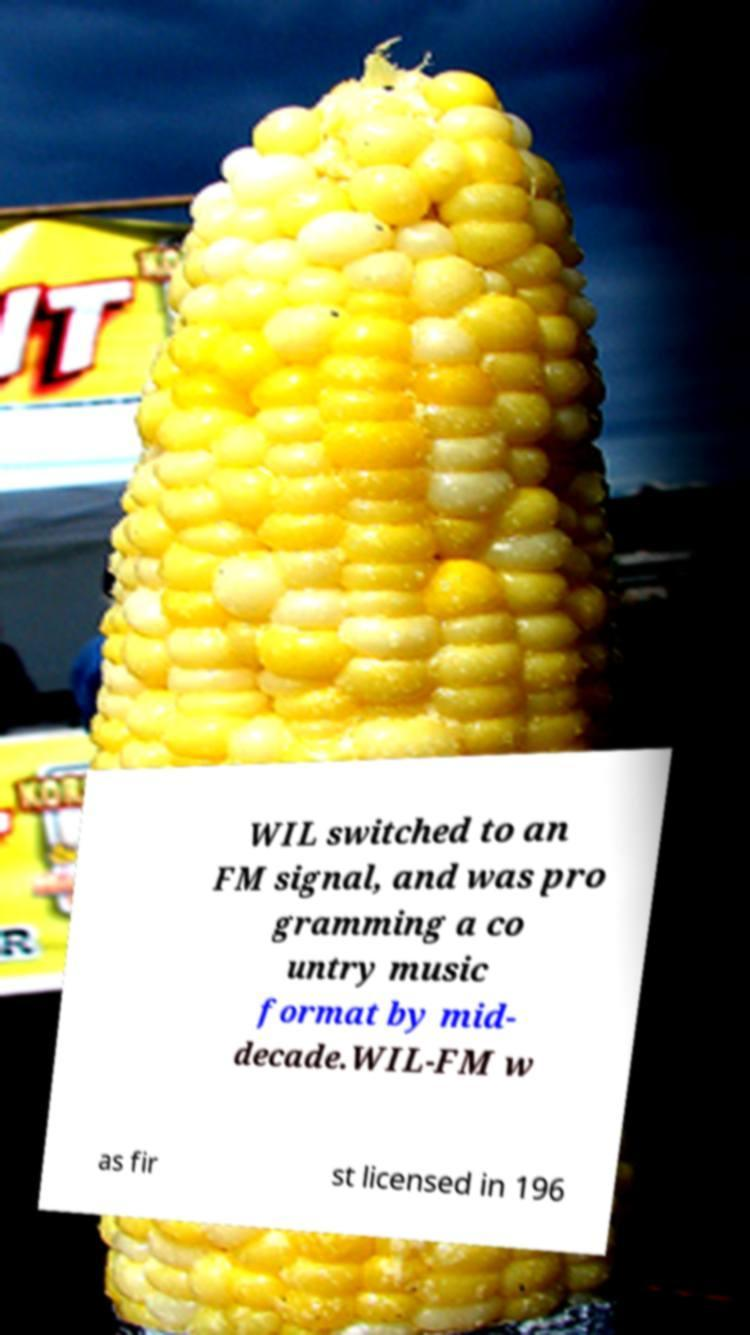I need the written content from this picture converted into text. Can you do that? WIL switched to an FM signal, and was pro gramming a co untry music format by mid- decade.WIL-FM w as fir st licensed in 196 